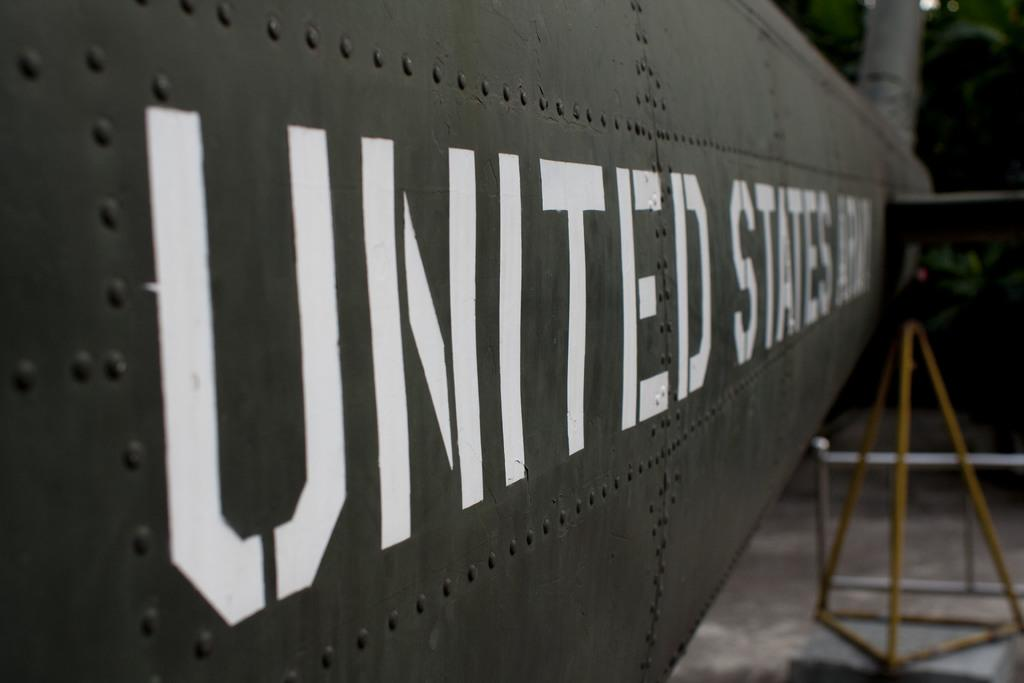What is written or displayed on the metal door in the image? There is text on a metal door in the image. Can you describe anything else visible in the background of the image? There is a stand visible in the background of the image. Where are the scissors located in the image? There are no scissors present in the image. Can you provide an example of the text on the metal door in the image? Since we cannot see the actual text in the image, we cannot provide an example of it. 